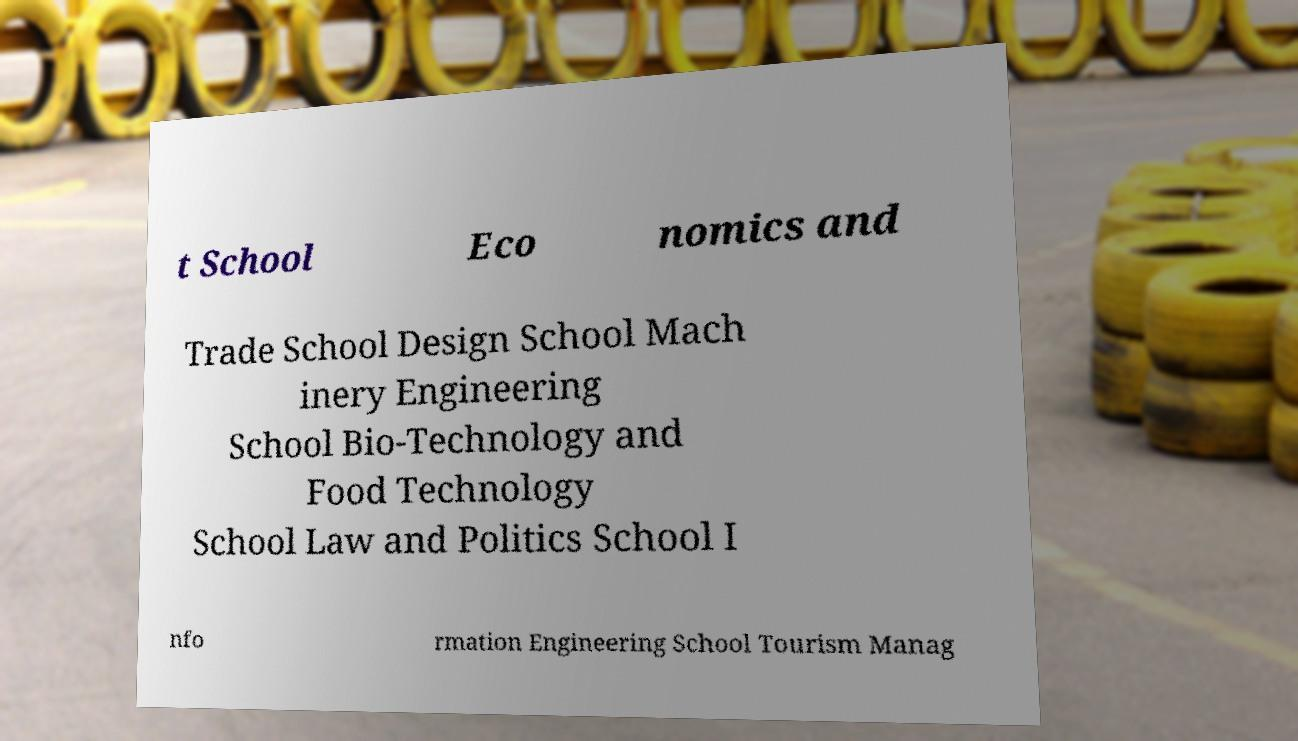Could you assist in decoding the text presented in this image and type it out clearly? t School Eco nomics and Trade School Design School Mach inery Engineering School Bio-Technology and Food Technology School Law and Politics School I nfo rmation Engineering School Tourism Manag 